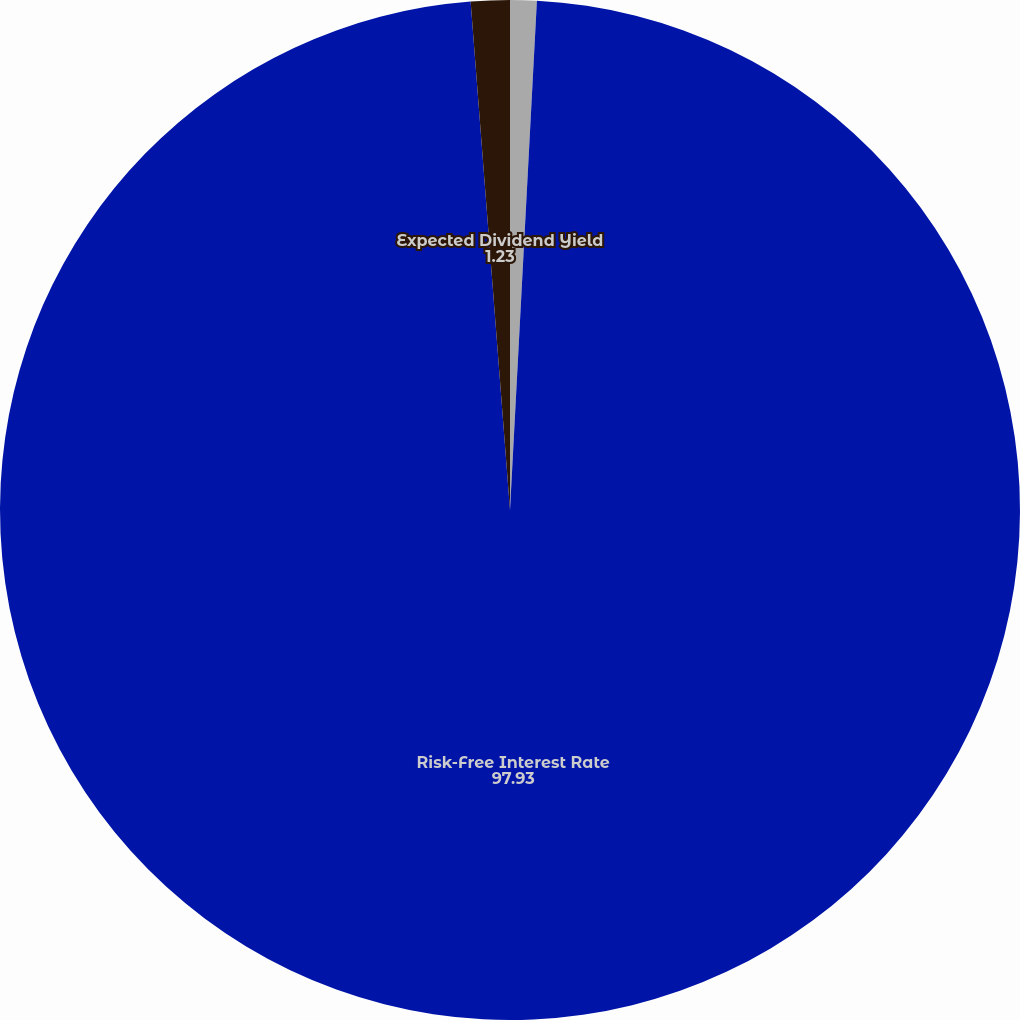Convert chart. <chart><loc_0><loc_0><loc_500><loc_500><pie_chart><fcel>Expected Stock Price Volatility<fcel>Risk-Free Interest Rate<fcel>Expected Dividend Yield<nl><fcel>0.84%<fcel>97.93%<fcel>1.23%<nl></chart> 